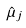<formula> <loc_0><loc_0><loc_500><loc_500>\hat { \mu } _ { j }</formula> 